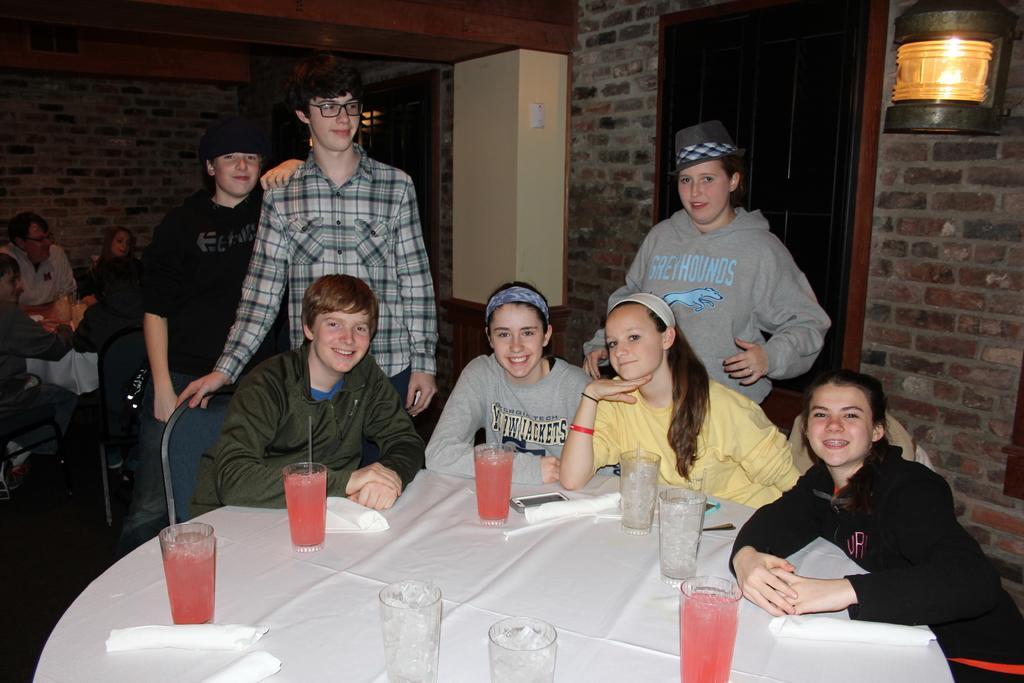Can you describe this image briefly? In the image we can see there are people who are sitting on chair and at the back the people are standing and on the table there are juice glasses. 